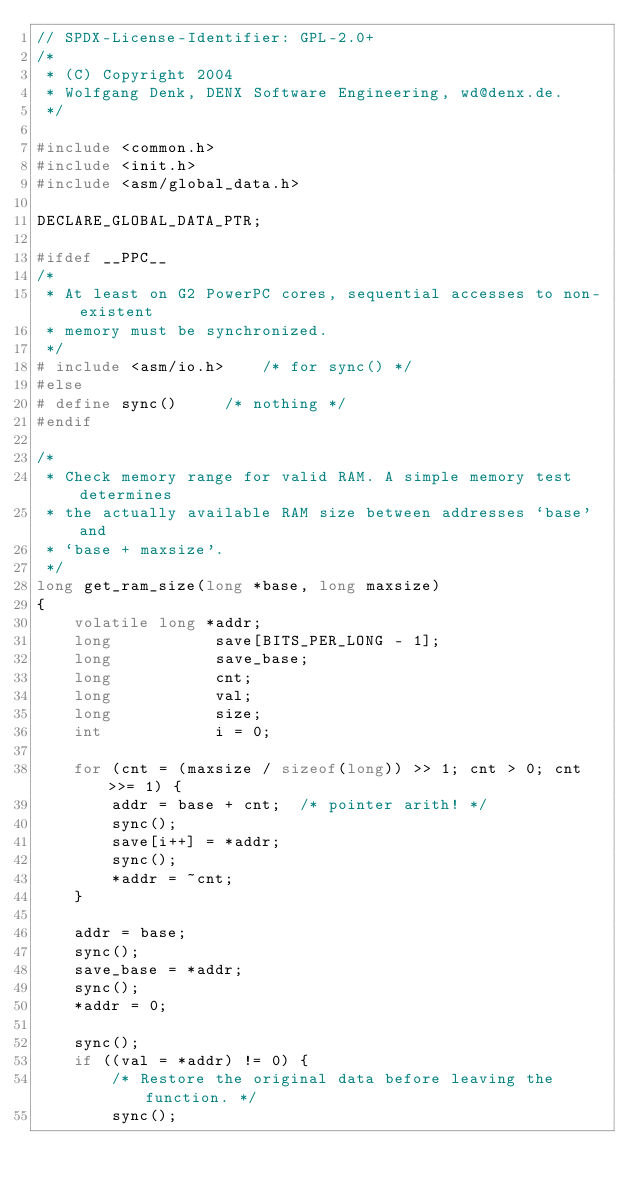Convert code to text. <code><loc_0><loc_0><loc_500><loc_500><_C_>// SPDX-License-Identifier: GPL-2.0+
/*
 * (C) Copyright 2004
 * Wolfgang Denk, DENX Software Engineering, wd@denx.de.
 */

#include <common.h>
#include <init.h>
#include <asm/global_data.h>

DECLARE_GLOBAL_DATA_PTR;

#ifdef __PPC__
/*
 * At least on G2 PowerPC cores, sequential accesses to non-existent
 * memory must be synchronized.
 */
# include <asm/io.h>	/* for sync() */
#else
# define sync()		/* nothing */
#endif

/*
 * Check memory range for valid RAM. A simple memory test determines
 * the actually available RAM size between addresses `base' and
 * `base + maxsize'.
 */
long get_ram_size(long *base, long maxsize)
{
	volatile long *addr;
	long           save[BITS_PER_LONG - 1];
	long           save_base;
	long           cnt;
	long           val;
	long           size;
	int            i = 0;

	for (cnt = (maxsize / sizeof(long)) >> 1; cnt > 0; cnt >>= 1) {
		addr = base + cnt;	/* pointer arith! */
		sync();
		save[i++] = *addr;
		sync();
		*addr = ~cnt;
	}

	addr = base;
	sync();
	save_base = *addr;
	sync();
	*addr = 0;

	sync();
	if ((val = *addr) != 0) {
		/* Restore the original data before leaving the function. */
		sync();</code> 